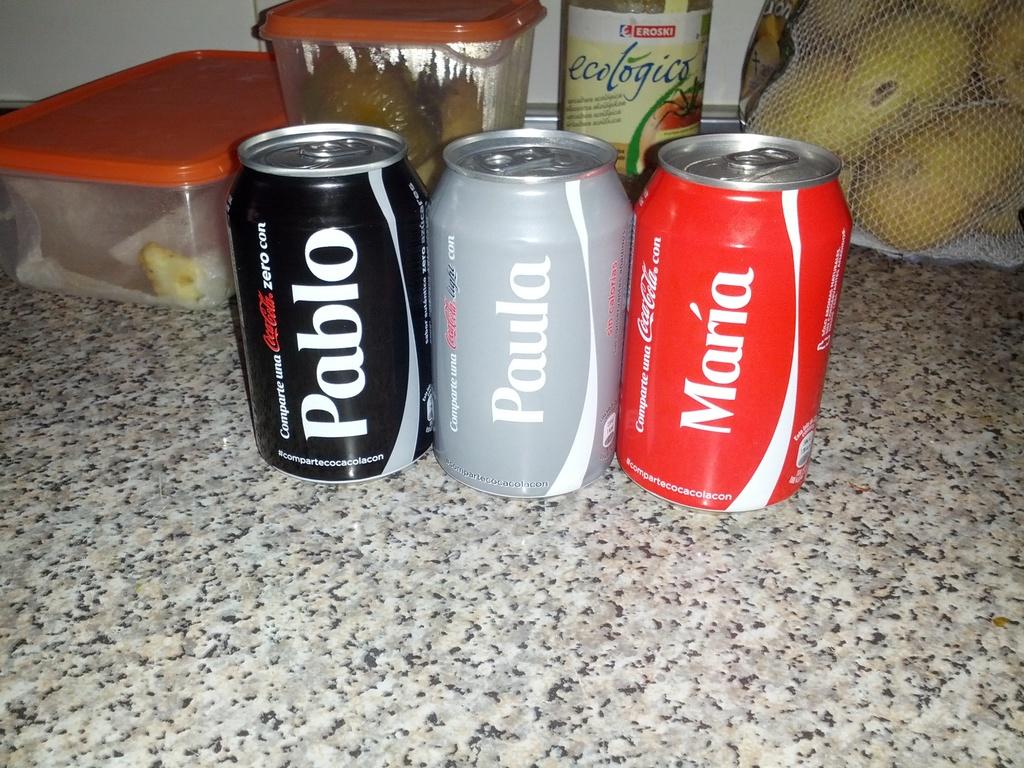Who's name are on these coke cans?
Offer a terse response. Pablo, paula, maria. 